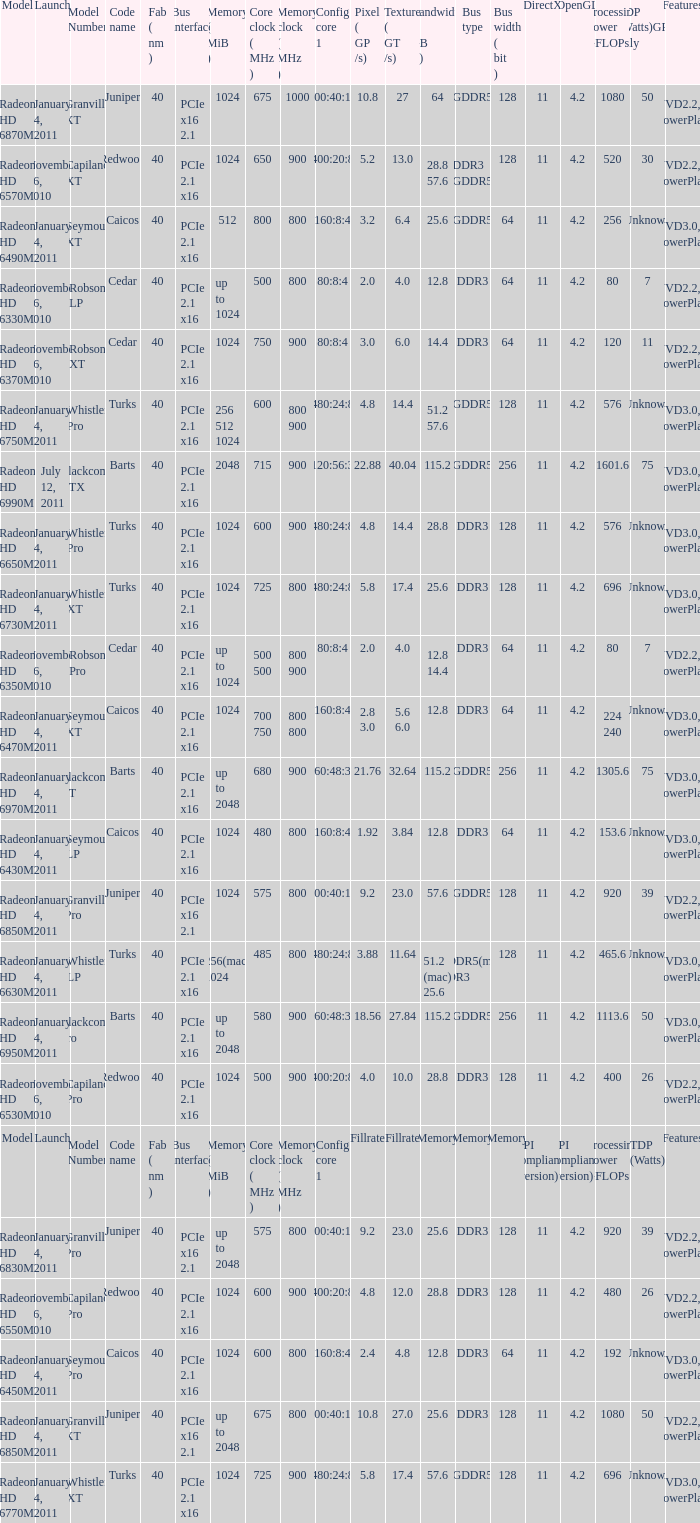What is the value for congi core 1 if the code name is Redwood and core clock(mhz) is 500? 400:20:8. 